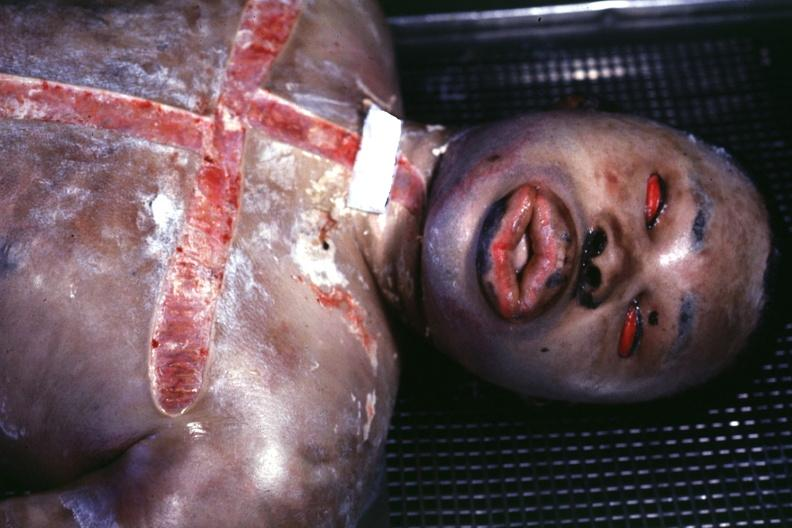what does this image show?
Answer the question using a single word or phrase. Burn case with view of face showing grotesque edema 